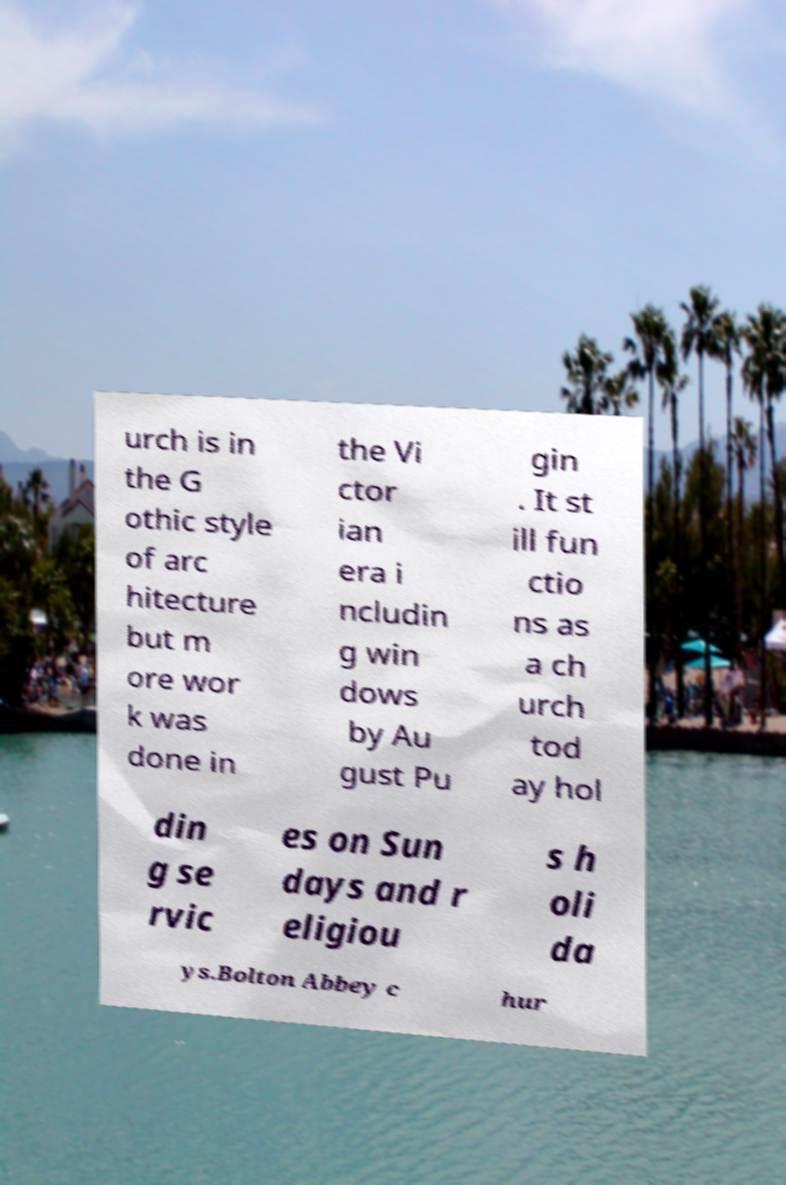Can you read and provide the text displayed in the image?This photo seems to have some interesting text. Can you extract and type it out for me? urch is in the G othic style of arc hitecture but m ore wor k was done in the Vi ctor ian era i ncludin g win dows by Au gust Pu gin . It st ill fun ctio ns as a ch urch tod ay hol din g se rvic es on Sun days and r eligiou s h oli da ys.Bolton Abbey c hur 